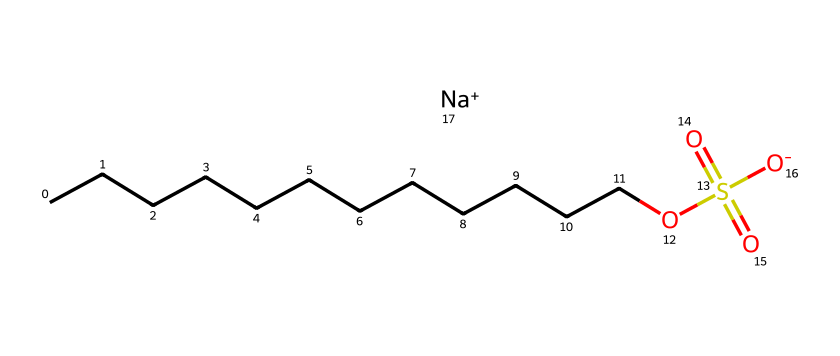What is the full name of this compound? The SMILES representation indicates that the compound consists of a 12-carbon chain (from CCCCCCCCCCCC) and a sulfate group (from OS(=O)(=O)[O-]), along with a sodium ion ([Na+]). Therefore, the full name is sodium lauryl sulfate.
Answer: sodium lauryl sulfate How many carbon atoms are present in this compound? The long carbon chain represented by CCCCCCCCCCCC indicates there are 12 carbon atoms in total.
Answer: 12 What functional group is present in this chemical structure? The sulfate group (OS(=O)(=O)[O-]) indicates the presence of a sulfate functional group in this compound, which is characteristic of surfactants.
Answer: sulfate What charge does the sodium ion carry? The sodium ion in the structure is denoted as [Na+], which shows that it carries a positive charge.
Answer: positive Why is this chemical considered a surfactant? The presence of a long hydrophobic carbon chain (the lauryl group) and a hydrophilic sulfate group allows this molecule to lower surface tension between liquids and solids, which is the key property of surfactants.
Answer: lowers surface tension What type of solubility can you expect from sodium lauryl sulfate? Due to its structure having both hydrophobic and hydrophilic parts, sodium lauryl sulfate is expected to be amphiphilic, thus making it soluble in both water and oils.
Answer: amphiphilic 